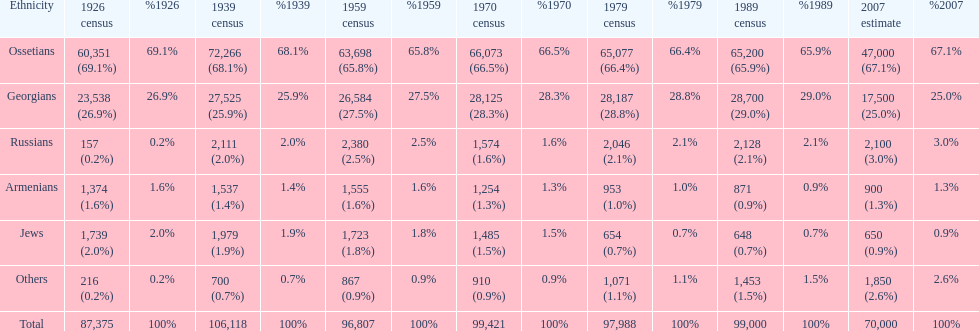How many ethnicity is there? 6. 